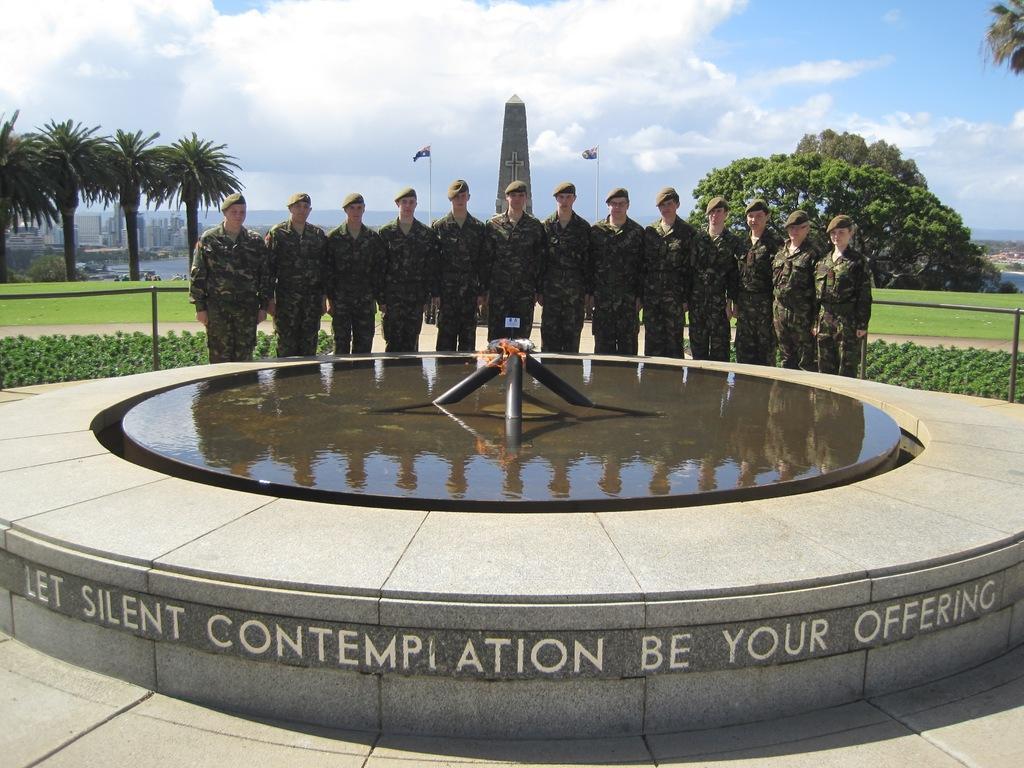Could you give a brief overview of what you see in this image? In this image we can see a group of people are standing near the fountain. There is a reflection of a group of people on the water surface. There is a grassy land in the image. There are many plants and trees in the image. There is a memorial pillar of the center in the image. There is a fencing in the image. There is a blue and a slightly cloudy sky in the image. There is a lake in the image. There are many buildings at the left side of the image. 